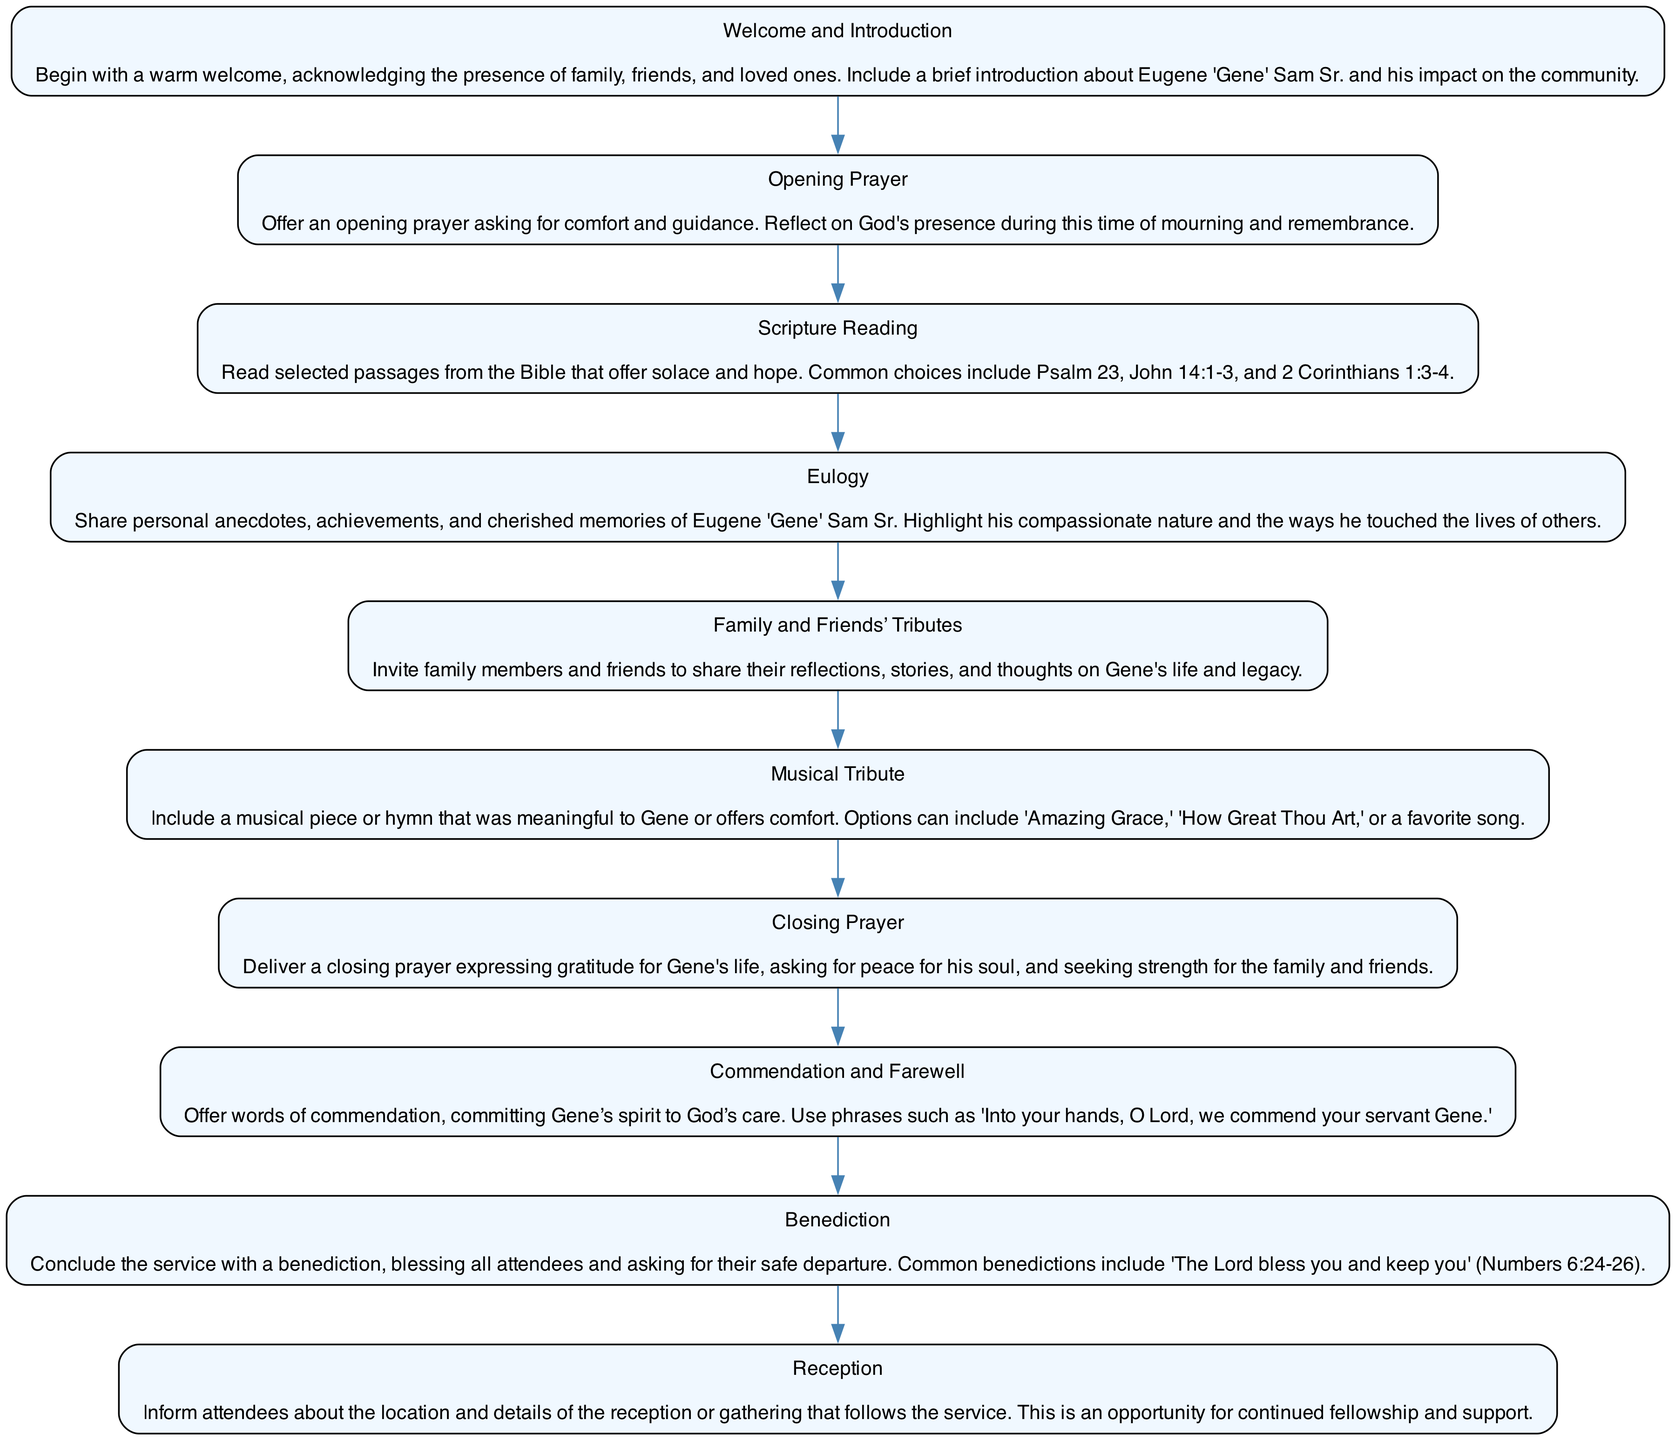What is the first step in the funeral service? The first step in the funeral service, as indicated by the flow chart, is to welcome and introduce the attendees and acknowledge Eugene "Gene" Sam Sr.'s impact.
Answer: Welcome and Introduction How many total steps are there in the service flow? By counting the elements listed in the diagram, there are a total of ten distinct steps in the service flow.
Answer: 10 What follows after the eulogy in the flow chart? The flow chart indicates that the step following the eulogy is the invitation for family and friends to share their tributes and reflections on Gene's life.
Answer: Family and Friends’ Tributes Which step includes music? In the flow chart, the step that specifically includes music is labeled as "Musical Tribute," inviting a meaningful song or hymn.
Answer: Musical Tribute What is the purpose of the closing prayer? The purpose of the closing prayer, as outlined in the flow chart, is to express gratitude for Gene's life and seek peace for his soul and strength for the family.
Answer: Deliver a closing prayer What are the two stages directly preceding the benediction? The two stages directly preceding the benediction in the diagram are "Commendation and Farewell" and the "Closing Prayer."
Answer: Commendation and Farewell, Closing Prayer What does the reception inform attendees about? The reception step informs attendees about the details of the gathering that will follow the service, providing an opportunity for fellowship.
Answer: Location and details of the reception What biblical theme is mentioned as part of the service? The flow chart mentions a scripture reading, including passages that offer solace and hope, such as Psalm 23.
Answer: Scripture Reading How is the overflow of the service concluded? The flow chart concludes the service with a benediction that blesses the attendees and wishes them a safe departure.
Answer: Benediction 